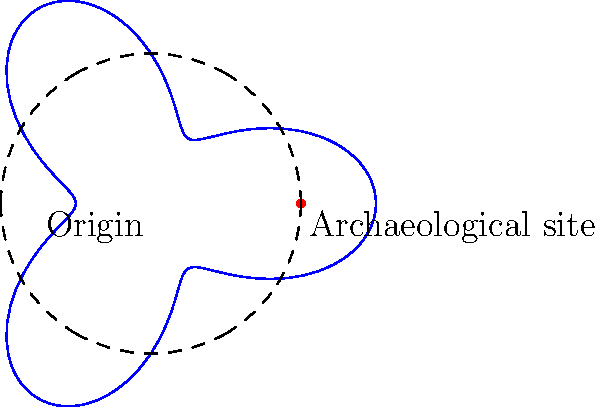In an archaeological study of ancient Roman settlements in Britain, researchers plotted the distribution of pottery finds using polar coordinates. The equation $r = 2 + \cos(3\theta)$ represents the concentration of pottery shards, where $r$ is measured in kilometers from a central archaeological site. What is the maximum distance from the central site where pottery concentrations are found? To find the maximum distance from the central site, we need to determine the maximum value of $r$ in the given equation:

1) The equation is given as $r = 2 + \cos(3\theta)$

2) We know that the cosine function oscillates between -1 and 1.

3) The maximum value of $r$ will occur when $\cos(3\theta)$ is at its maximum, which is 1.

4) Substituting this into our equation:

   $r_{max} = 2 + 1 = 3$

5) Therefore, the maximum distance from the central site is 3 kilometers.

This result indicates that the highest concentrations of pottery shards are found in a pattern extending up to 3 kilometers from the central archaeological site, which could suggest the extent of Roman influence or trade in this particular settlement.
Answer: 3 kilometers 